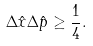<formula> <loc_0><loc_0><loc_500><loc_500>\Delta \hat { x } \Delta \hat { p } \geq \frac { 1 } { 4 } .</formula> 